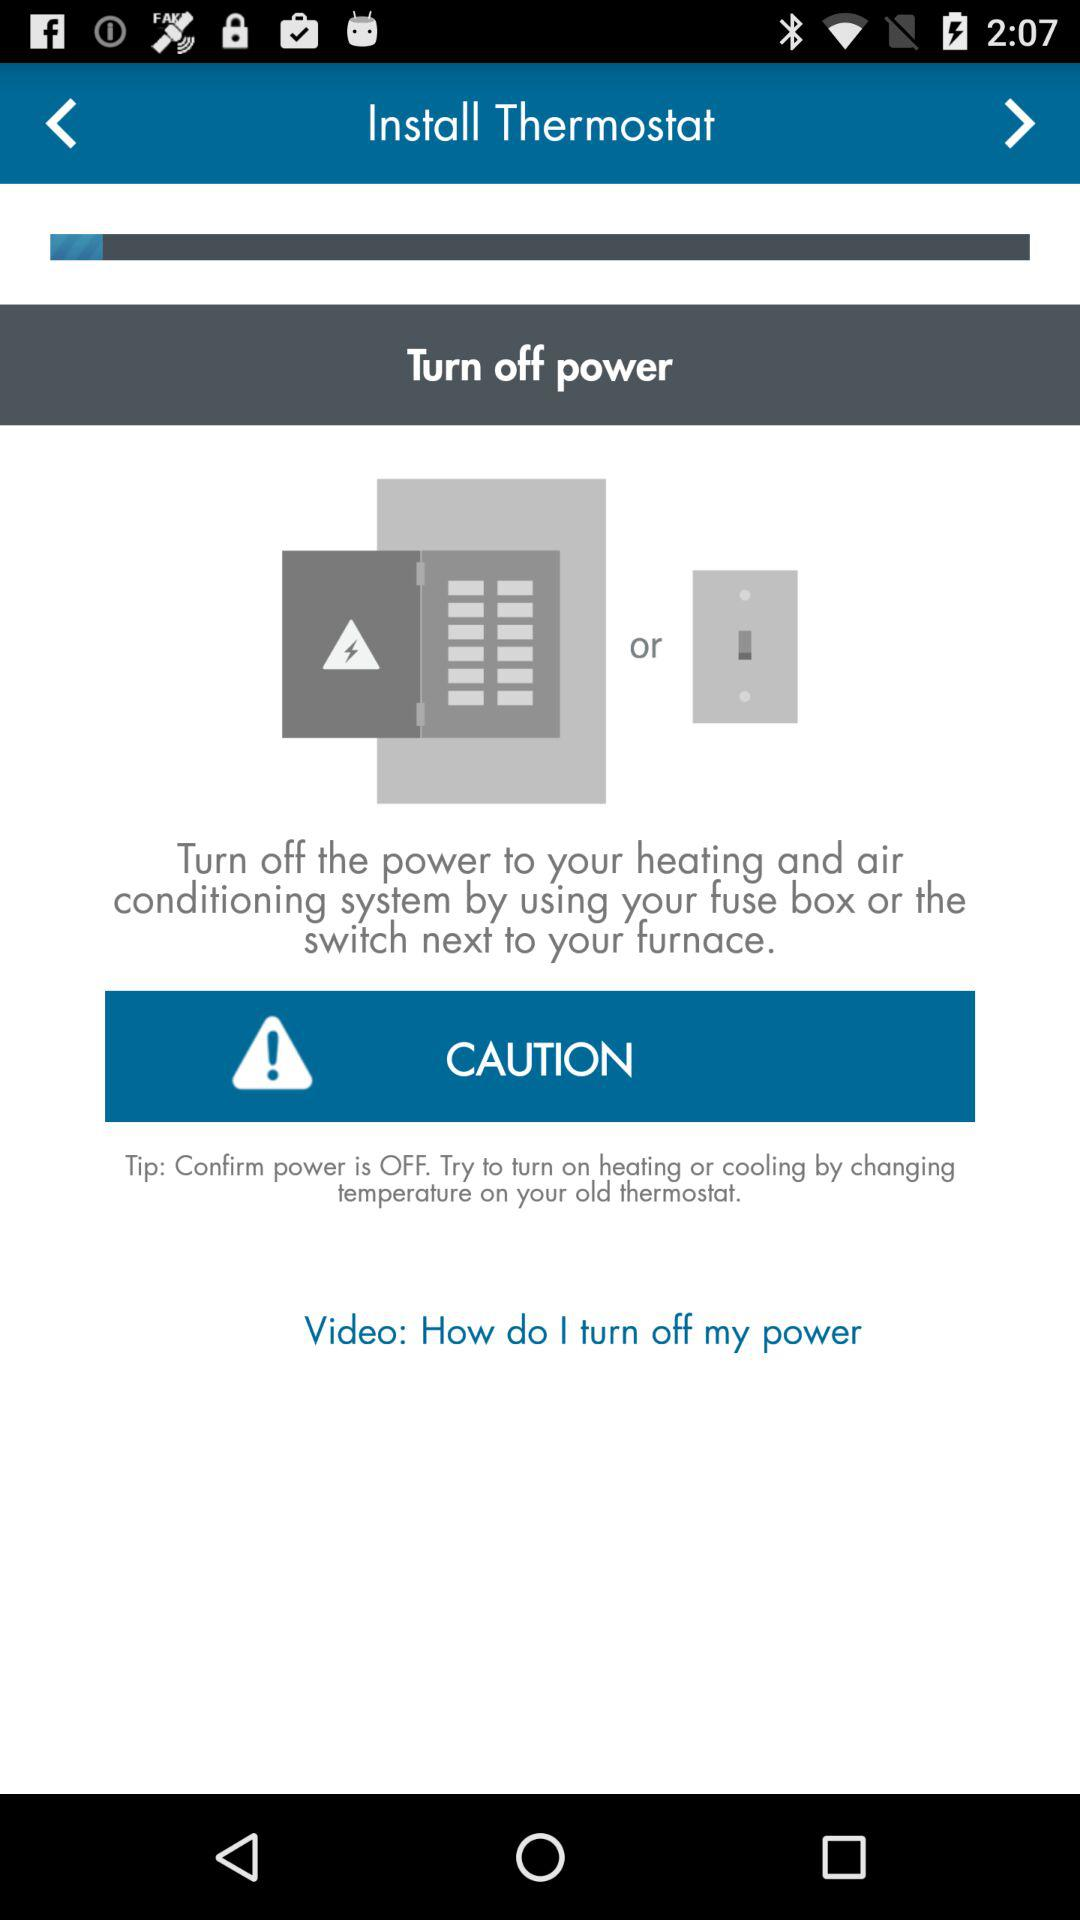What is the name of the application? The name of the application is "Thermostat". 